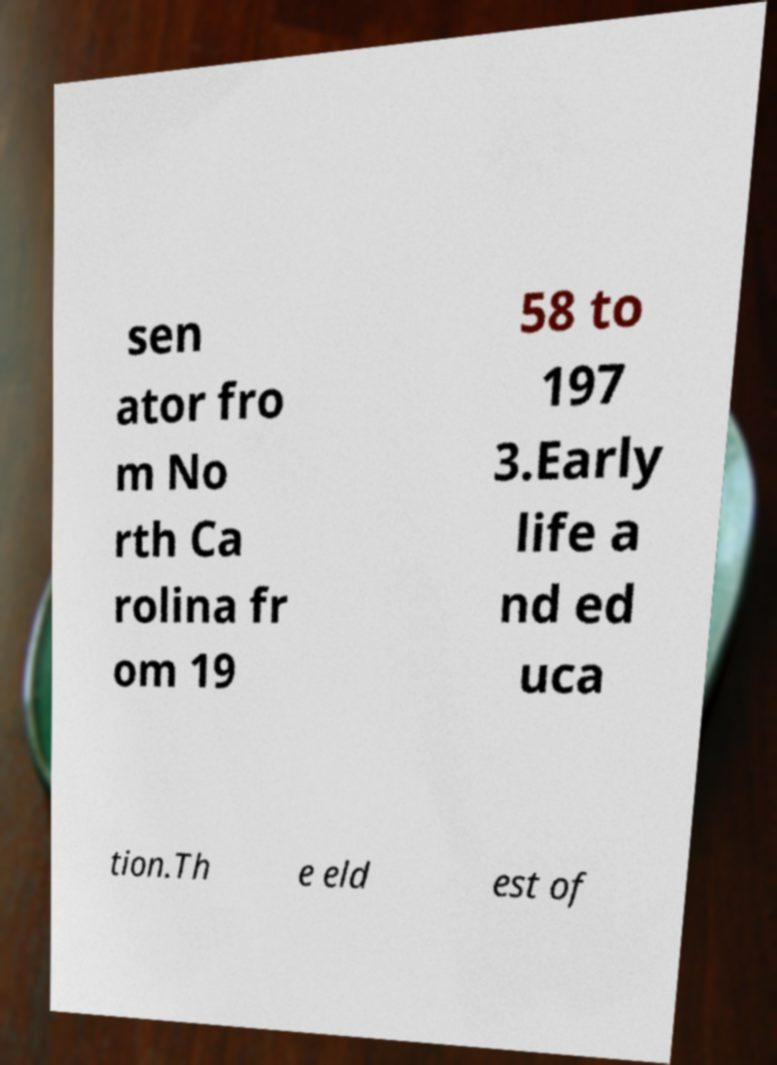Can you accurately transcribe the text from the provided image for me? sen ator fro m No rth Ca rolina fr om 19 58 to 197 3.Early life a nd ed uca tion.Th e eld est of 